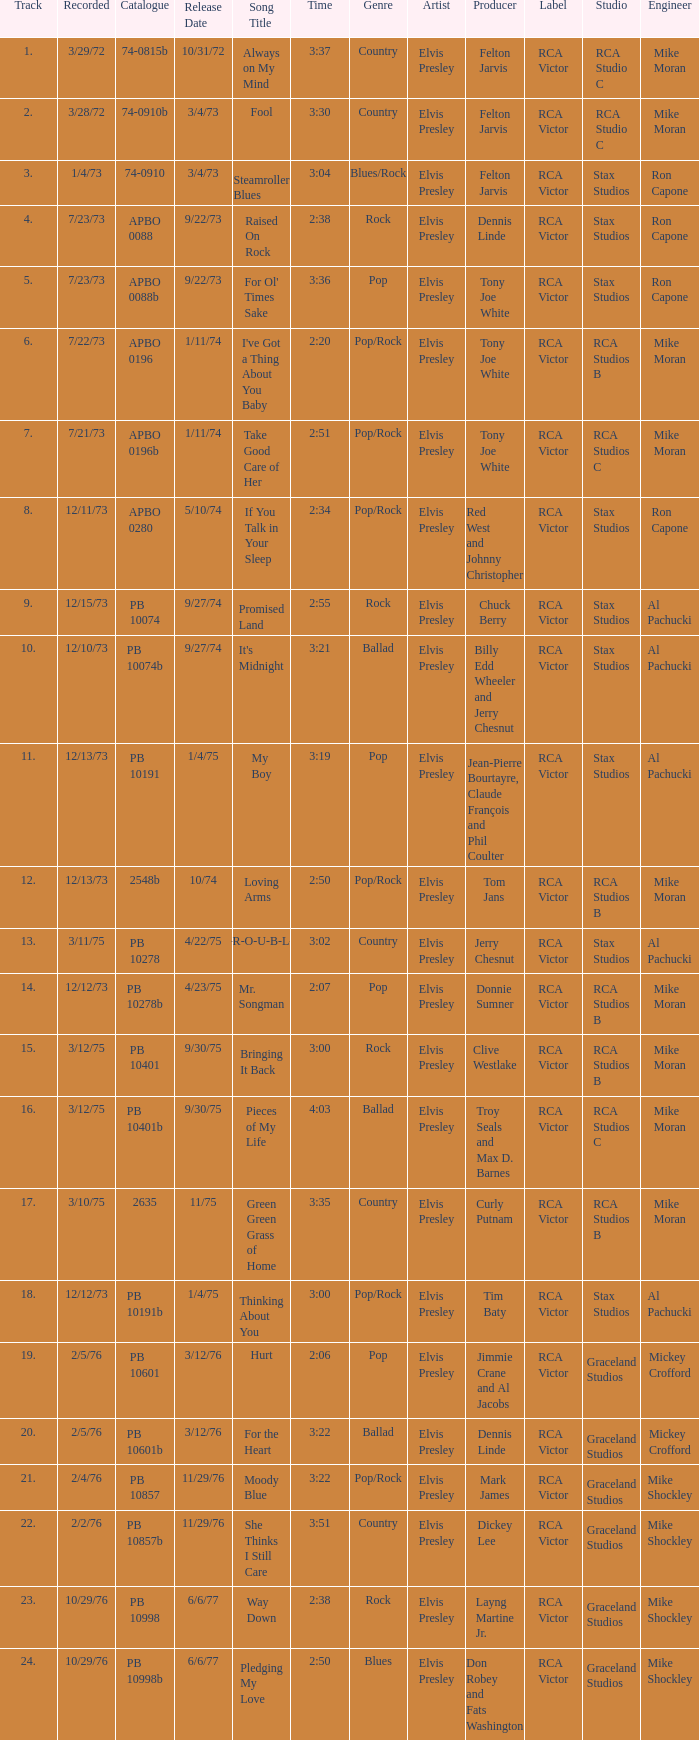Tell me the time for 6/6/77 release date and song title of way down 2:38. 